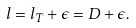<formula> <loc_0><loc_0><loc_500><loc_500>l = l _ { T } + \epsilon = D + \epsilon .</formula> 